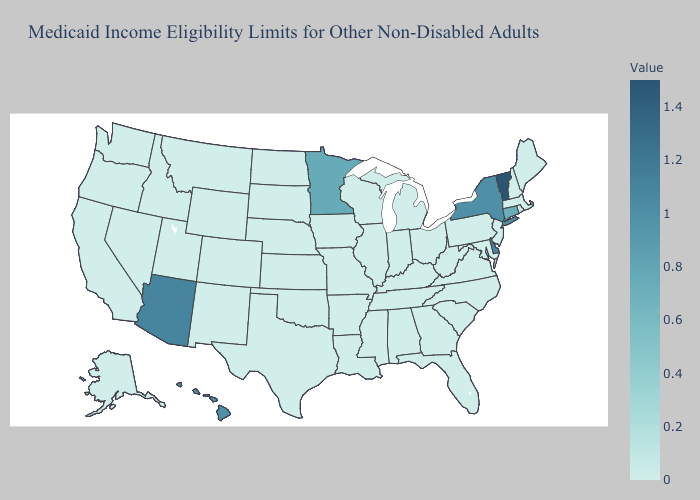Does Vermont have the lowest value in the Northeast?
Give a very brief answer. No. Among the states that border Michigan , which have the lowest value?
Answer briefly. Indiana, Ohio, Wisconsin. Among the states that border Washington , which have the highest value?
Keep it brief. Idaho, Oregon. Among the states that border North Dakota , does Minnesota have the lowest value?
Short answer required. No. Among the states that border Vermont , which have the lowest value?
Answer briefly. Massachusetts, New Hampshire. 